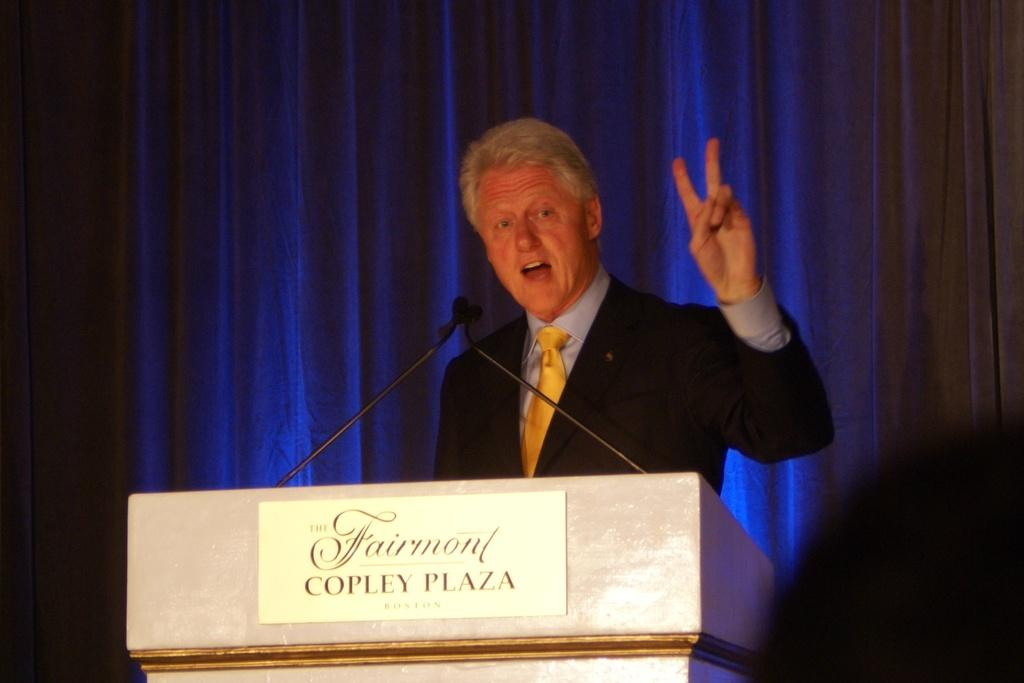<image>
Relay a brief, clear account of the picture shown. President Clinton stands behind a podium with a sign that reads Fairmont Copley Plaza. 